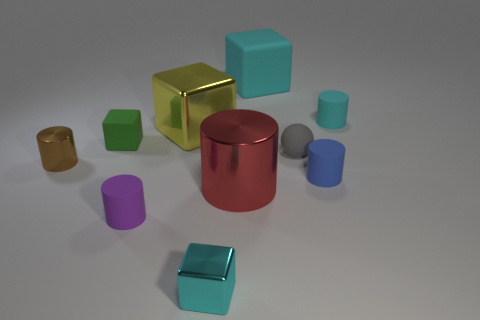Do the metal cylinder on the left side of the small purple matte object and the small cylinder that is behind the tiny brown thing have the same color?
Keep it short and to the point. No. What material is the cyan thing to the right of the large thing behind the small cyan matte object?
Your answer should be very brief. Rubber. There is a rubber block that is the same size as the sphere; what is its color?
Give a very brief answer. Green. Is the shape of the small purple object the same as the small cyan thing in front of the small metallic cylinder?
Your response must be concise. No. What shape is the small metallic object that is the same color as the large rubber thing?
Your response must be concise. Cube. There is a tiny block on the right side of the shiny block behind the gray thing; what number of small blocks are in front of it?
Keep it short and to the point. 0. What is the size of the block behind the cyan object on the right side of the tiny gray rubber thing?
Make the answer very short. Large. The cyan block that is made of the same material as the ball is what size?
Provide a succinct answer. Large. There is a cyan thing that is behind the big red object and to the left of the gray object; what shape is it?
Your answer should be very brief. Cube. Are there an equal number of rubber cubes in front of the small brown metal thing and big shiny cubes?
Provide a succinct answer. No. 